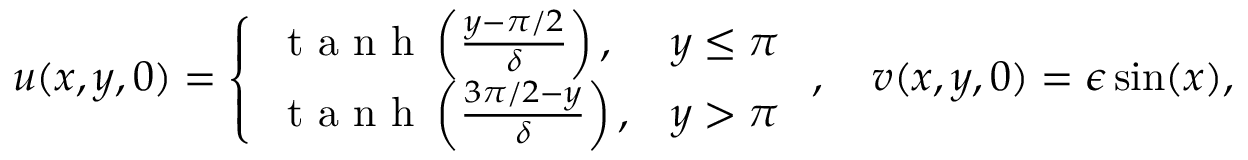<formula> <loc_0><loc_0><loc_500><loc_500>u ( x , y , 0 ) = \left \{ \begin{array} { l l } { t a n h \left ( \frac { y - \pi / 2 } { \delta } \right ) , } & { y \leq \pi } \\ { t a n h \left ( \frac { 3 \pi / 2 - y } { \delta } \right ) , } & { y > \pi } \end{array} , \quad v ( x , y , 0 ) = \epsilon \sin ( x ) ,</formula> 